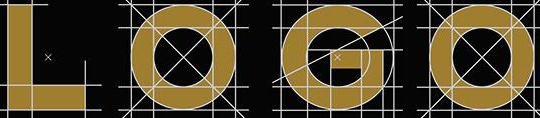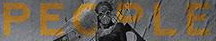What words are shown in these images in order, separated by a semicolon? LOGO; PEOPLE 